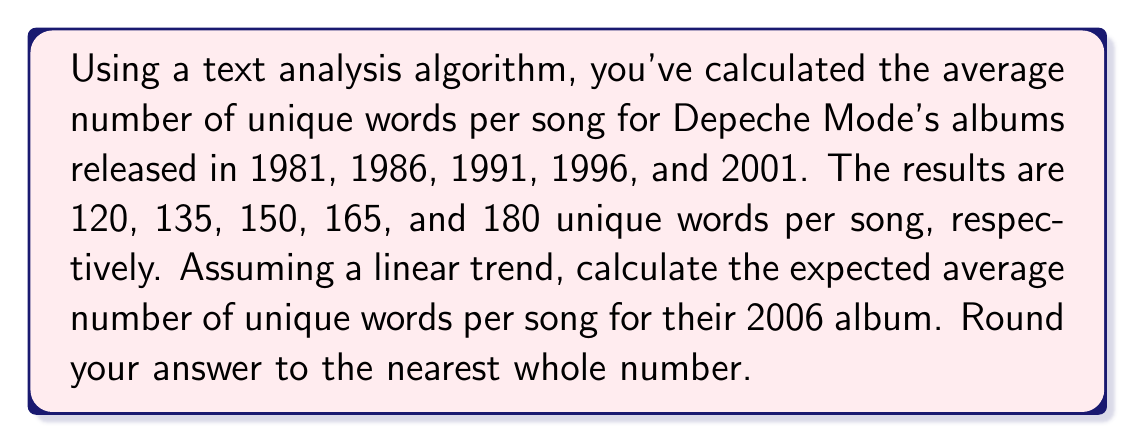Show me your answer to this math problem. To solve this problem, we'll use linear regression to determine the trend in lyrical complexity over time. Let's follow these steps:

1) Let x represent the years since 1981, and y represent the number of unique words per song.

2) Our data points are:
   (0, 120), (5, 135), (10, 150), (15, 165), (20, 180)

3) To find the linear trend, we need to calculate the slope (m) and y-intercept (b) of the line y = mx + b.

4) For the slope, we can use the formula:
   $$ m = \frac{\sum_{i=1}^{n} (x_i - \bar{x})(y_i - \bar{y})}{\sum_{i=1}^{n} (x_i - \bar{x})^2} $$

5) Calculate the means:
   $\bar{x} = \frac{0 + 5 + 10 + 15 + 20}{5} = 10$
   $\bar{y} = \frac{120 + 135 + 150 + 165 + 180}{5} = 150$

6) Calculate the numerator and denominator:
   Numerator: $(-10)(120-150) + (-5)(135-150) + (0)(150-150) + (5)(165-150) + (10)(180-150) = 1500$
   Denominator: $(-10)^2 + (-5)^2 + 0^2 + 5^2 + 10^2 = 250$

7) Calculate the slope:
   $m = \frac{1500}{250} = 6$

8) Use the point-slope form to find b:
   $150 = 6(10) + b$
   $b = 90$

9) Our linear equation is:
   $y = 6x + 90$

10) For 2006, x = 25 (years since 1981). Plug this into our equation:
    $y = 6(25) + 90 = 240$

Therefore, the expected average number of unique words per song for the 2006 album is 240.
Answer: 240 